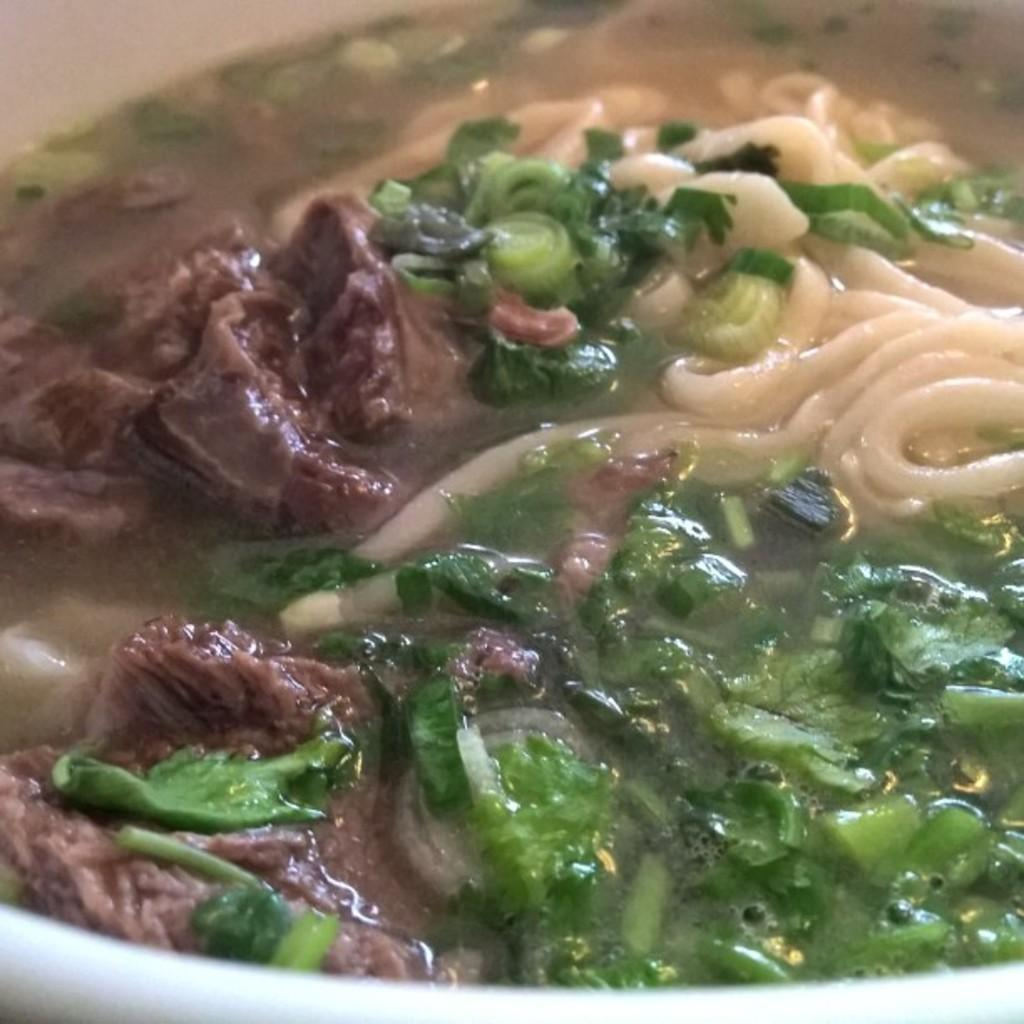What type of food item is in the image? There is a food item in the image that contains soup and noodles. What are the main ingredients of the food item? The main ingredients of the food item are soup and noodles. Are there any other items in the bowl besides the soup and noodles? Yes, there are other items in the bowl. What type of shoes is the man wearing in the image? There is no man present in the image, so it is not possible to determine what type of shoes he might be wearing. 